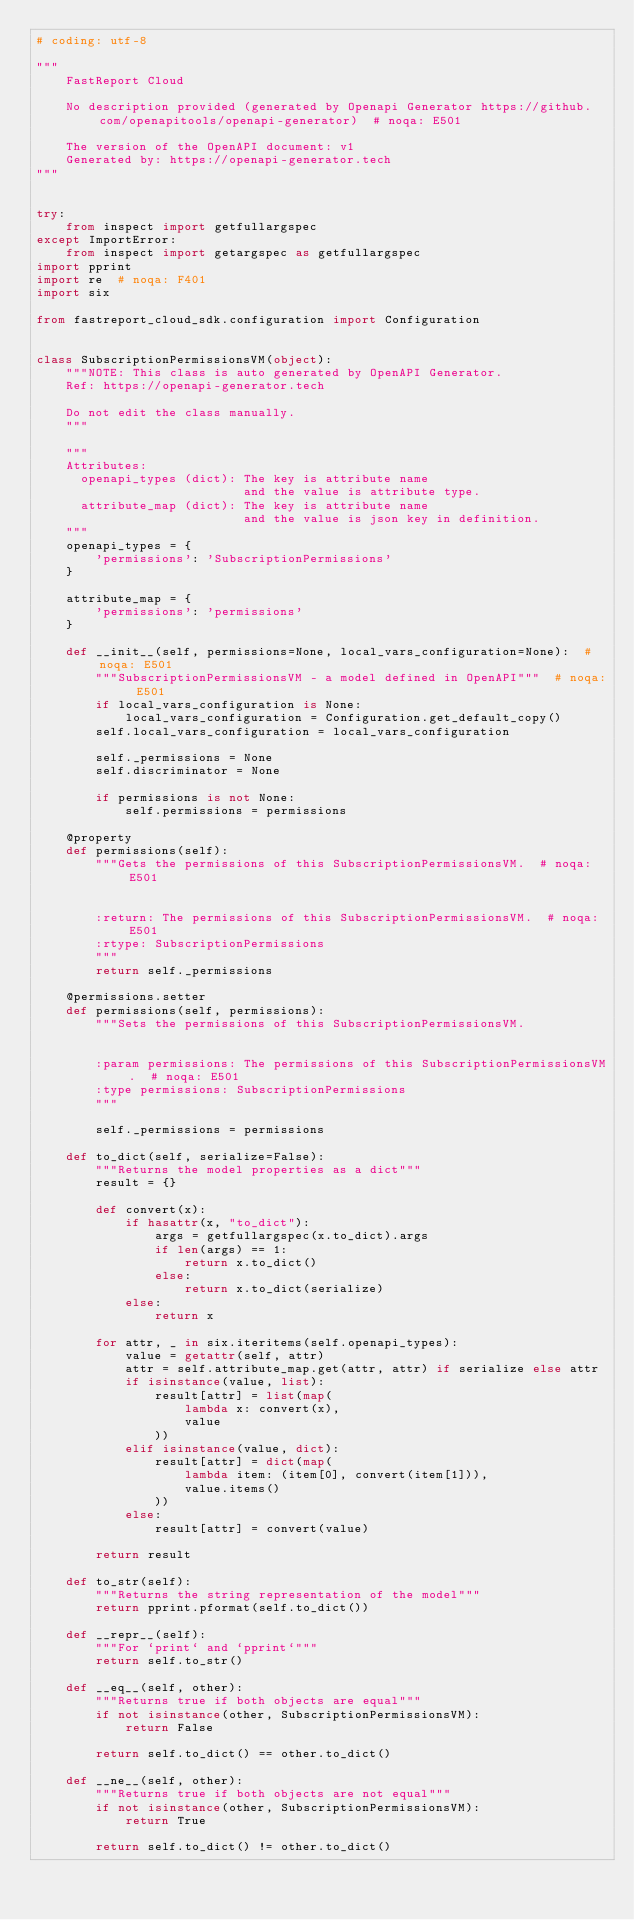<code> <loc_0><loc_0><loc_500><loc_500><_Python_># coding: utf-8

"""
    FastReport Cloud

    No description provided (generated by Openapi Generator https://github.com/openapitools/openapi-generator)  # noqa: E501

    The version of the OpenAPI document: v1
    Generated by: https://openapi-generator.tech
"""


try:
    from inspect import getfullargspec
except ImportError:
    from inspect import getargspec as getfullargspec
import pprint
import re  # noqa: F401
import six

from fastreport_cloud_sdk.configuration import Configuration


class SubscriptionPermissionsVM(object):
    """NOTE: This class is auto generated by OpenAPI Generator.
    Ref: https://openapi-generator.tech

    Do not edit the class manually.
    """

    """
    Attributes:
      openapi_types (dict): The key is attribute name
                            and the value is attribute type.
      attribute_map (dict): The key is attribute name
                            and the value is json key in definition.
    """
    openapi_types = {
        'permissions': 'SubscriptionPermissions'
    }

    attribute_map = {
        'permissions': 'permissions'
    }

    def __init__(self, permissions=None, local_vars_configuration=None):  # noqa: E501
        """SubscriptionPermissionsVM - a model defined in OpenAPI"""  # noqa: E501
        if local_vars_configuration is None:
            local_vars_configuration = Configuration.get_default_copy()
        self.local_vars_configuration = local_vars_configuration

        self._permissions = None
        self.discriminator = None

        if permissions is not None:
            self.permissions = permissions

    @property
    def permissions(self):
        """Gets the permissions of this SubscriptionPermissionsVM.  # noqa: E501


        :return: The permissions of this SubscriptionPermissionsVM.  # noqa: E501
        :rtype: SubscriptionPermissions
        """
        return self._permissions

    @permissions.setter
    def permissions(self, permissions):
        """Sets the permissions of this SubscriptionPermissionsVM.


        :param permissions: The permissions of this SubscriptionPermissionsVM.  # noqa: E501
        :type permissions: SubscriptionPermissions
        """

        self._permissions = permissions

    def to_dict(self, serialize=False):
        """Returns the model properties as a dict"""
        result = {}

        def convert(x):
            if hasattr(x, "to_dict"):
                args = getfullargspec(x.to_dict).args
                if len(args) == 1:
                    return x.to_dict()
                else:
                    return x.to_dict(serialize)
            else:
                return x

        for attr, _ in six.iteritems(self.openapi_types):
            value = getattr(self, attr)
            attr = self.attribute_map.get(attr, attr) if serialize else attr
            if isinstance(value, list):
                result[attr] = list(map(
                    lambda x: convert(x),
                    value
                ))
            elif isinstance(value, dict):
                result[attr] = dict(map(
                    lambda item: (item[0], convert(item[1])),
                    value.items()
                ))
            else:
                result[attr] = convert(value)

        return result

    def to_str(self):
        """Returns the string representation of the model"""
        return pprint.pformat(self.to_dict())

    def __repr__(self):
        """For `print` and `pprint`"""
        return self.to_str()

    def __eq__(self, other):
        """Returns true if both objects are equal"""
        if not isinstance(other, SubscriptionPermissionsVM):
            return False

        return self.to_dict() == other.to_dict()

    def __ne__(self, other):
        """Returns true if both objects are not equal"""
        if not isinstance(other, SubscriptionPermissionsVM):
            return True

        return self.to_dict() != other.to_dict()
</code> 